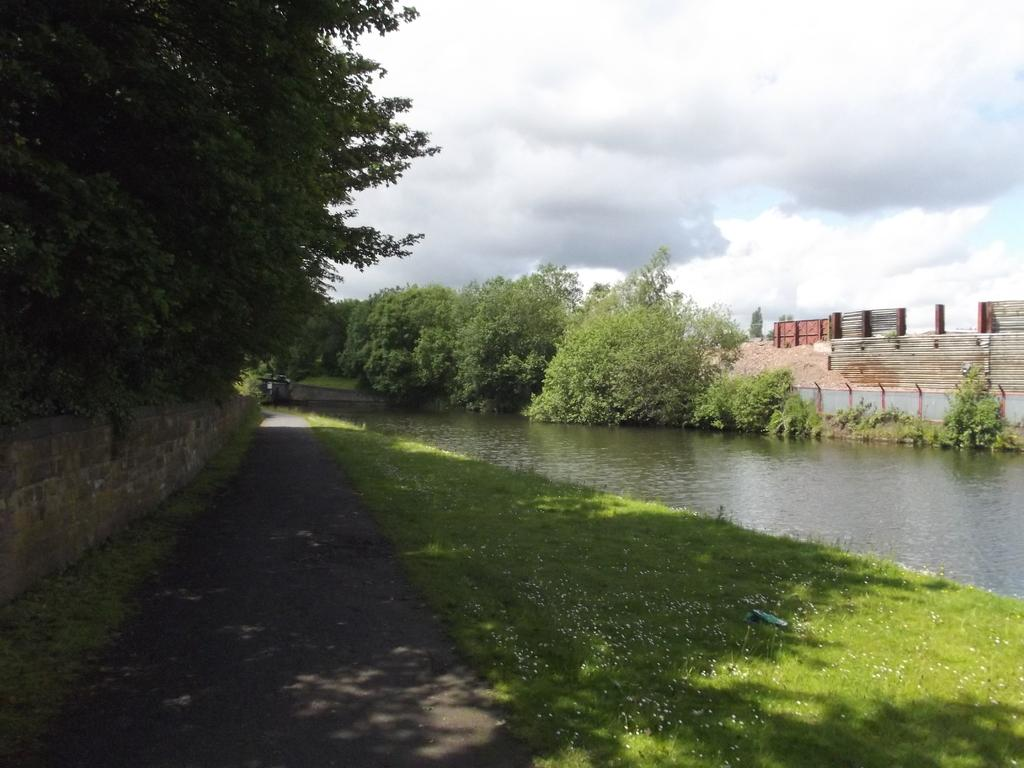What type of vegetation can be seen in the image? There is grass in the image. What else can be seen besides grass? There is water, trees, and a fence visible in the image. What is visible in the background of the image? The sky is visible in the background of the image. What type of branch is your sister holding in the image? There is no person, let alone a sister, present in the image. Additionally, there is no branch visible. 